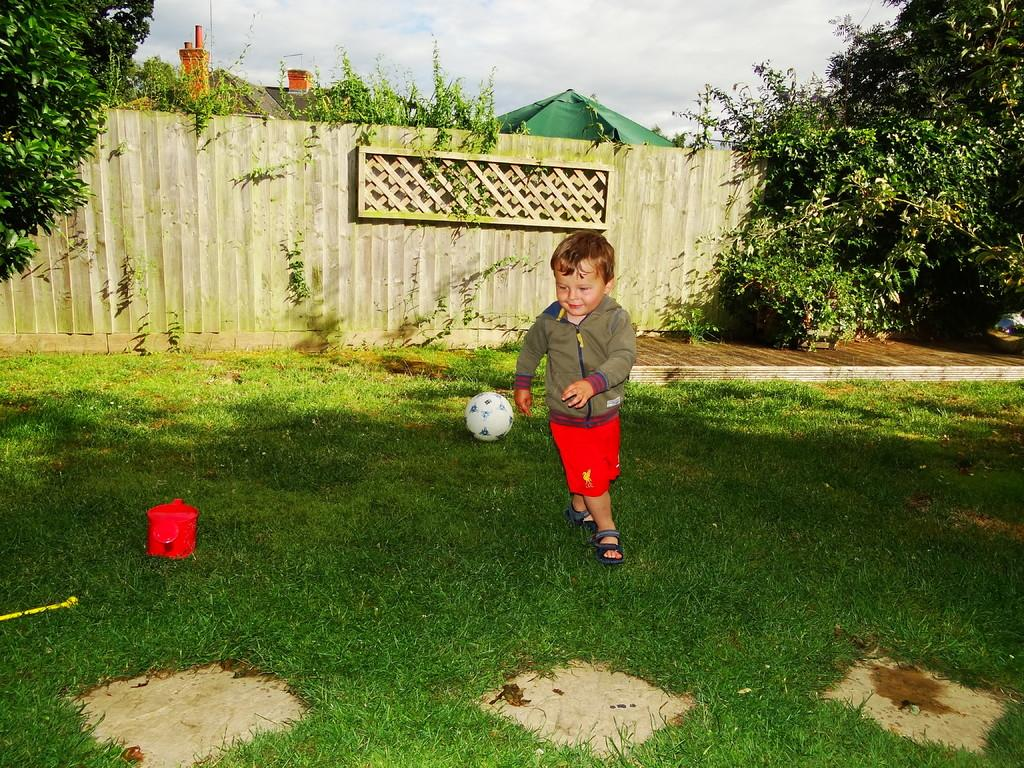Who is the main subject in the image? There is a boy in the image. What is the boy doing in the image? The boy is playing with a ball. Where is the boy located in the image? The boy is in the grass. What can be seen behind the boy in the image? There is a wall behind the boy. What type of vegetation is visible in the image? There are trees visible in the image. What else can be seen in the background of the image? Roofs of houses are visible in the image. What is the condition of the sky in the image? The sky is clear in the image. Can you tell me how many spies are hiding behind the trees in the image? There are no spies present in the image; it features a boy playing with a ball in the grass. What type of lettuce is growing on the roofs of the houses in the image? There is no lettuce visible in the image; only the roofs of houses are visible in the background. 